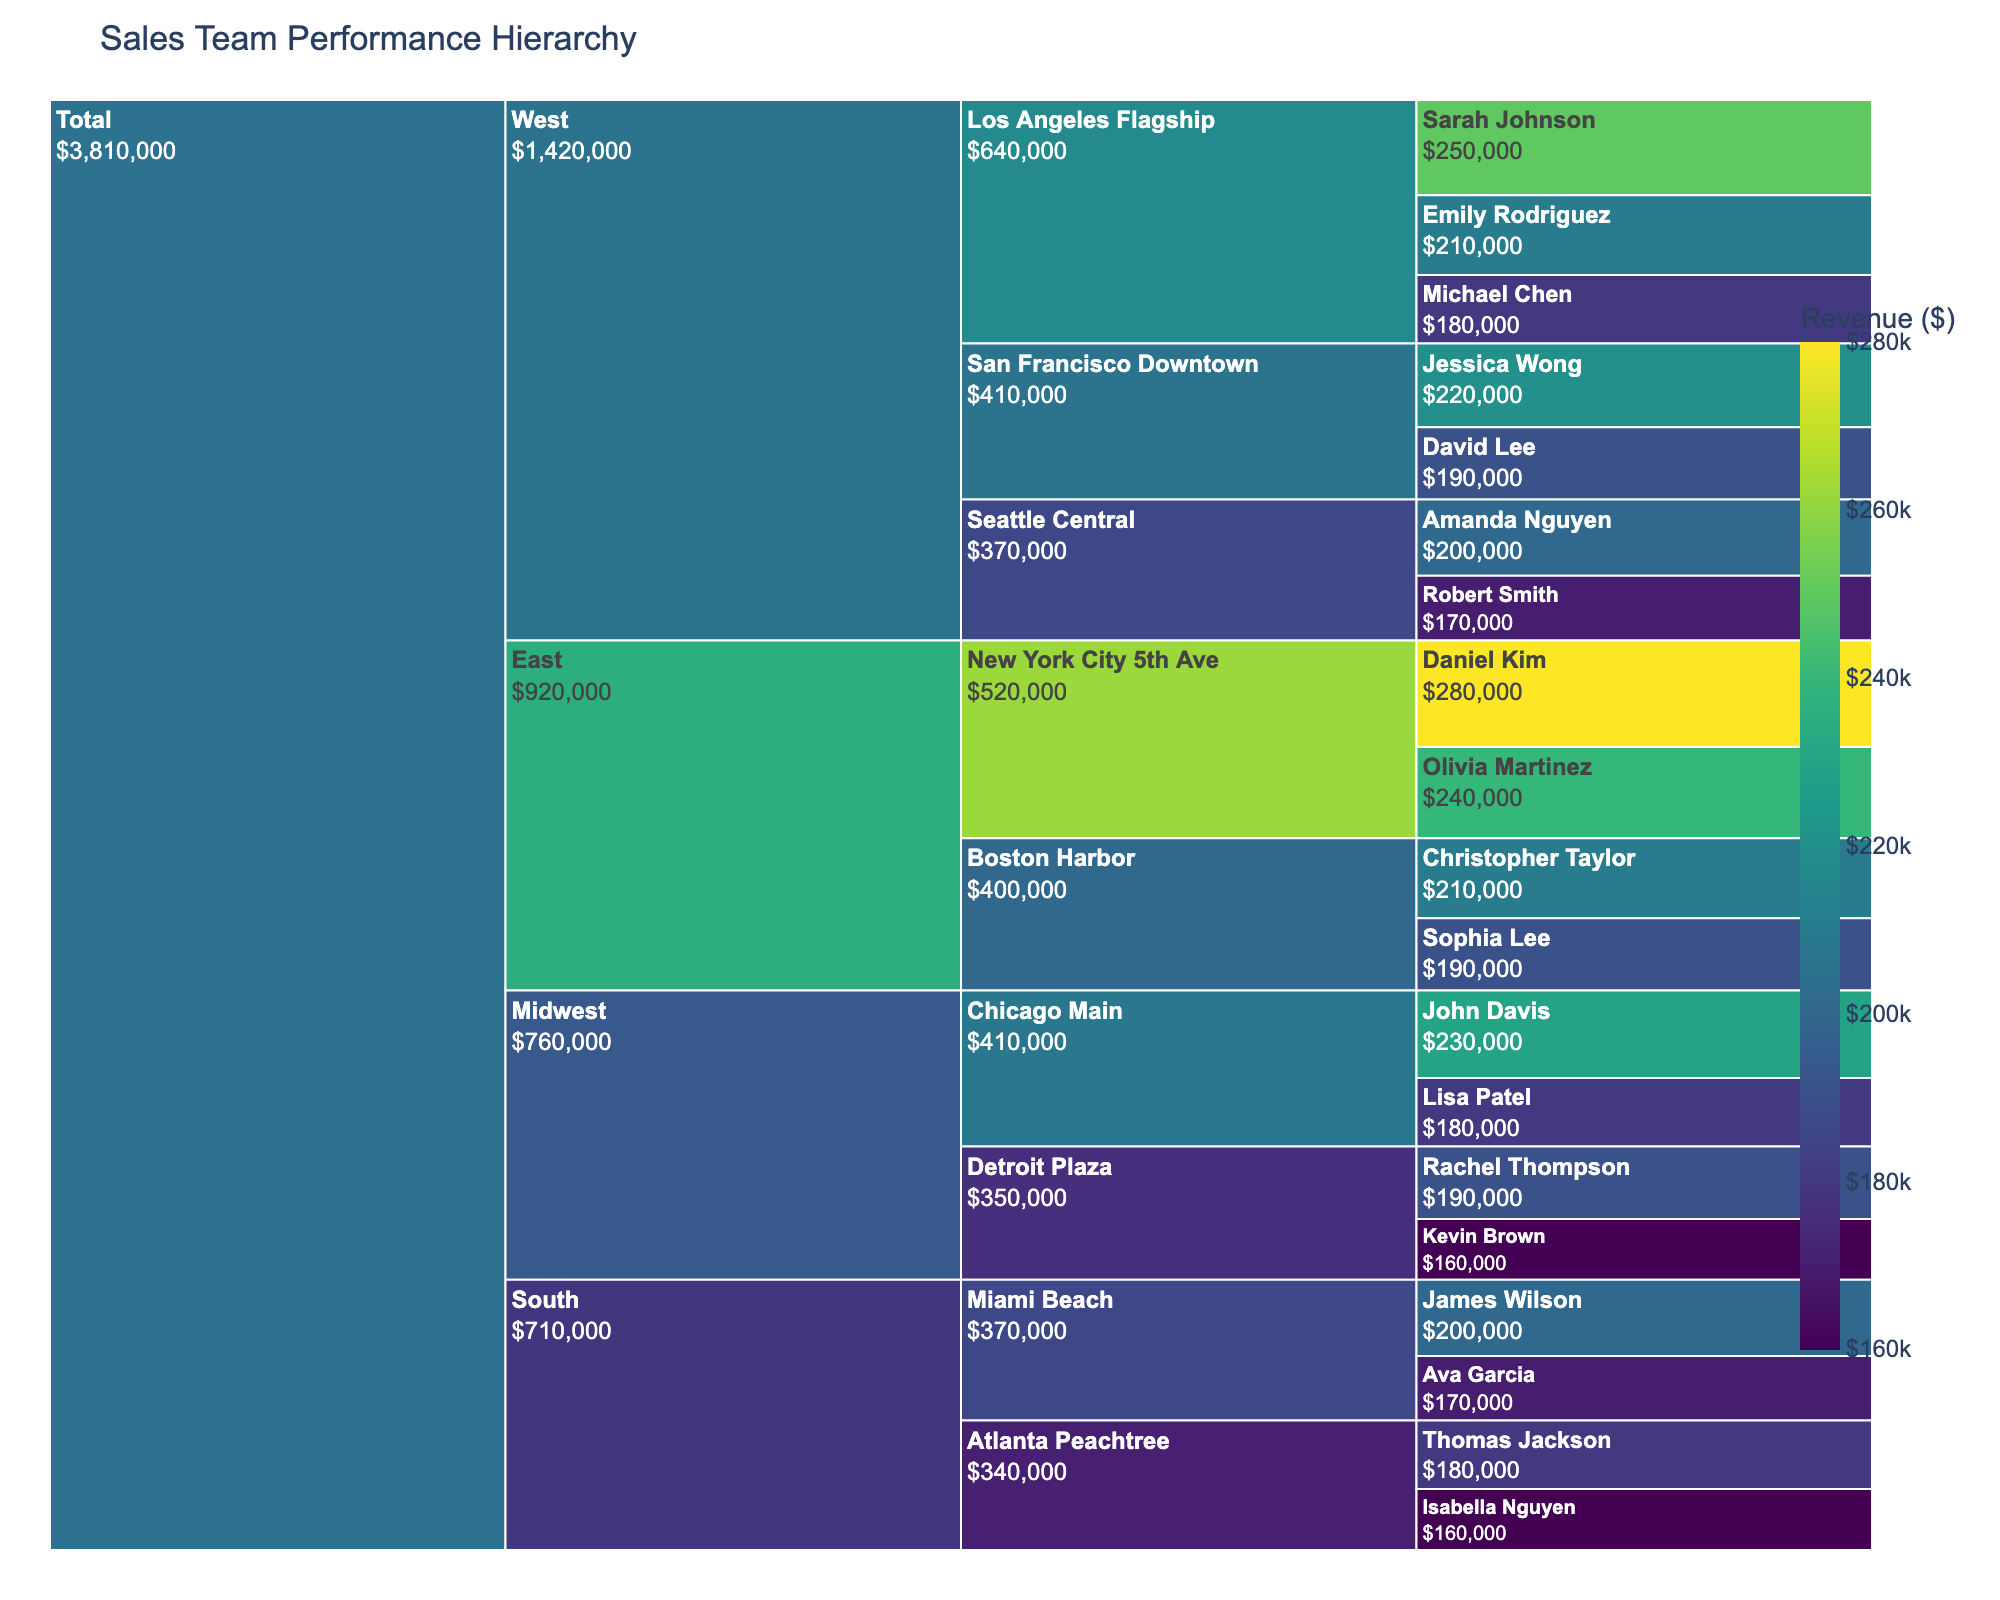What's the total revenue from the 'West' region? First, locate the 'West' region in the Icicle Chart. Then sum up the revenue of all salespersons within the 'West' region across all stores. The sum includes: 250000, 180000, 210000, 190000, 220000, 170000, 200000. The total is 1420000.
Answer: 1,420,000 Which salesperson contributed the highest revenue in the 'East' region? Navigate to the 'East' region and find the highest individual revenue under 'East'. Daniel Kim has the highest individual contribution with 280000 in the New York City 5th Ave store.
Answer: Daniel Kim How does the revenue of the top salesperson from 'East' compare to the top salesperson from 'South'? The top salesperson from 'East' is Daniel Kim with 280000. The top salesperson from 'South' is James Wilson with 200000. Daniel Kim has a higher revenue by 80000.
Answer: East > South by 80,000 What is the combined revenue of the 'New York City 5th Ave' and 'Los Angeles Flagship' stores? Identify the revenue for each salesperson in the 'New York City 5th Ave' store: 280000 and 240000. Sum these to get 520000. Similarly, sum the individual contributions in 'Los Angeles Flagship': 250000, 180000, 210000, which totals to 640000. Adding both sums results in 1160000.
Answer: 1,160,000 Which store in the 'Midwest' has the lowest revenue generation, and what is that revenue? In the 'Midwest' region, compare revenue totals: 'Chicago Main' (John Davis 230000 + Lisa Patel 180000 = 410000), and 'Detroit Plaza' (Kevin Brown 160000 + Rachel Thompson 190000 = 350000). The 'Detroit Plaza' store has the lowest revenue with 350000.
Answer: Detroit Plaza, 350,000 Is the total revenue generated by all stores in the 'South' region higher than the 'West' region store 'Seattle Central'? Sum the revenue for the 'South' region: 200000, 170000, 180000, 160000, which totals 710000. The total revenue for 'Seattle Central' is 170000 + 200000 = 370000. The ‘South’ region has significantly higher revenue than 'Seattle Central'.
Answer: Yes What's the average revenue of salespersons in 'Boston Harbor' store? Calculate total revenue in 'Boston Harbor' by adding the contributions: 210000 and 190000, totaling 400000. As there are 2 salespersons, the average is 400000 / 2 = 200000.
Answer: 200,000 